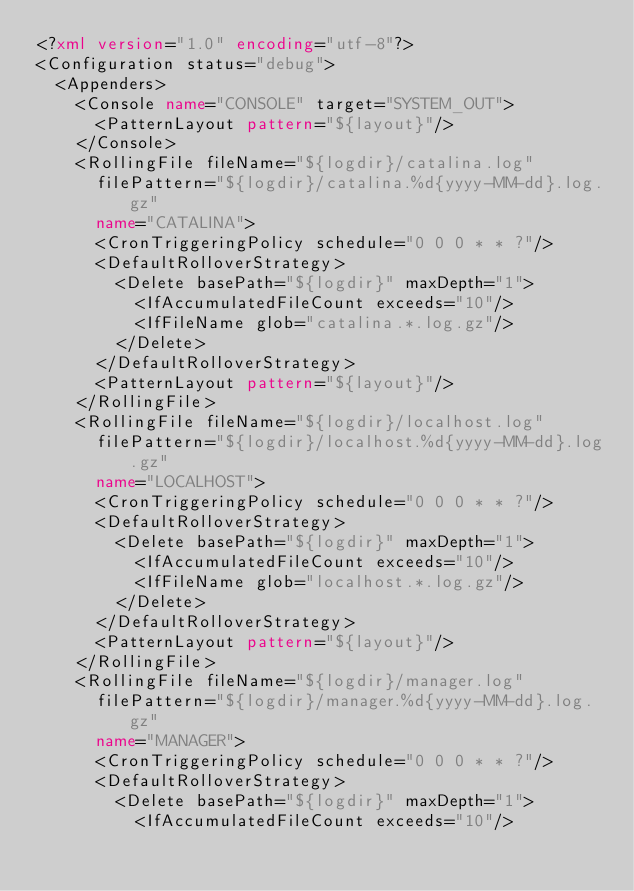<code> <loc_0><loc_0><loc_500><loc_500><_XML_><?xml version="1.0" encoding="utf-8"?>
<Configuration status="debug">
  <Appenders>
    <Console name="CONSOLE" target="SYSTEM_OUT">
      <PatternLayout pattern="${layout}"/>
    </Console>
    <RollingFile fileName="${logdir}/catalina.log"
      filePattern="${logdir}/catalina.%d{yyyy-MM-dd}.log.gz"
      name="CATALINA">
      <CronTriggeringPolicy schedule="0 0 0 * * ?"/>
      <DefaultRolloverStrategy>
        <Delete basePath="${logdir}" maxDepth="1">
          <IfAccumulatedFileCount exceeds="10"/>
          <IfFileName glob="catalina.*.log.gz"/>
        </Delete>
      </DefaultRolloverStrategy>
      <PatternLayout pattern="${layout}"/>
    </RollingFile>
    <RollingFile fileName="${logdir}/localhost.log"
      filePattern="${logdir}/localhost.%d{yyyy-MM-dd}.log.gz"
      name="LOCALHOST">
      <CronTriggeringPolicy schedule="0 0 0 * * ?"/>
      <DefaultRolloverStrategy>
        <Delete basePath="${logdir}" maxDepth="1">
          <IfAccumulatedFileCount exceeds="10"/>
          <IfFileName glob="localhost.*.log.gz"/>
        </Delete>
      </DefaultRolloverStrategy>
      <PatternLayout pattern="${layout}"/>
    </RollingFile>
    <RollingFile fileName="${logdir}/manager.log"
      filePattern="${logdir}/manager.%d{yyyy-MM-dd}.log.gz"
      name="MANAGER">
      <CronTriggeringPolicy schedule="0 0 0 * * ?"/>
      <DefaultRolloverStrategy>
        <Delete basePath="${logdir}" maxDepth="1">
          <IfAccumulatedFileCount exceeds="10"/></code> 